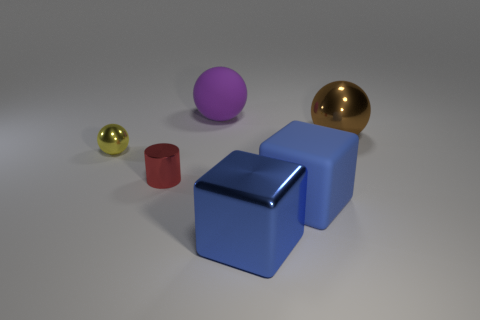There is a large object that is the same color as the metal block; what is its material?
Your answer should be compact. Rubber. What material is the big ball that is to the left of the big shiny object that is behind the shiny cylinder made of?
Your answer should be very brief. Rubber. Are there any small green cubes made of the same material as the large purple sphere?
Provide a short and direct response. No. What is the material of the purple thing that is the same size as the blue rubber block?
Make the answer very short. Rubber. There is a ball that is left of the small cylinder that is to the left of the shiny thing that is behind the tiny ball; what is its size?
Offer a very short reply. Small. There is a matte thing that is behind the matte block; is there a rubber cube behind it?
Ensure brevity in your answer.  No. There is a brown metallic thing; is it the same shape as the rubber thing in front of the cylinder?
Provide a short and direct response. No. What color is the ball left of the tiny red cylinder?
Offer a terse response. Yellow. How big is the shiny sphere to the left of the rubber object that is in front of the purple matte thing?
Your answer should be very brief. Small. Does the large metallic object to the left of the brown metal ball have the same shape as the red shiny object?
Offer a very short reply. No. 